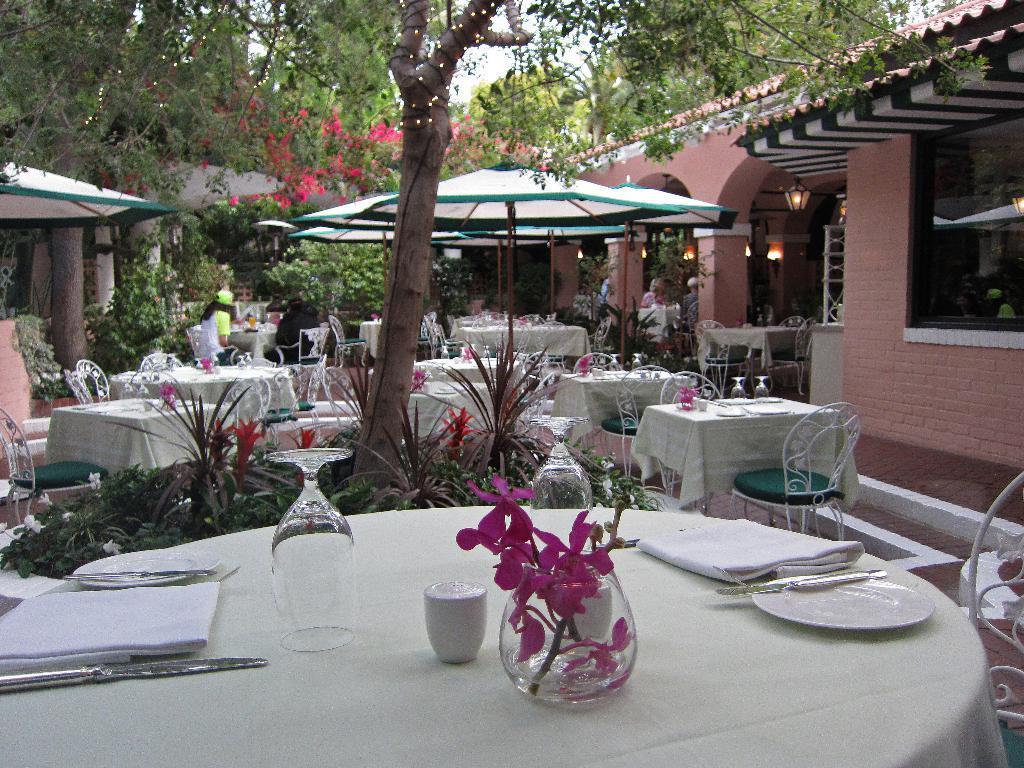Describe this image in one or two sentences. This picture is taken inside a restaurant. In this image, on the right side, we can see a glass window, a few tables, chairs, we can also see two people are sitting on the chair in front of the table. On the left side, we can see a cloth, trees, a few tables and chairs. In the middle of the image, we can see few tables and chairs, on that table, we can see a cloth, plate, knife, hand key, flower pot, flowers, glasses and a bottle. In the background, we can see a wooden trunk, with some plants, flowers. At the top, we can see a sky. 